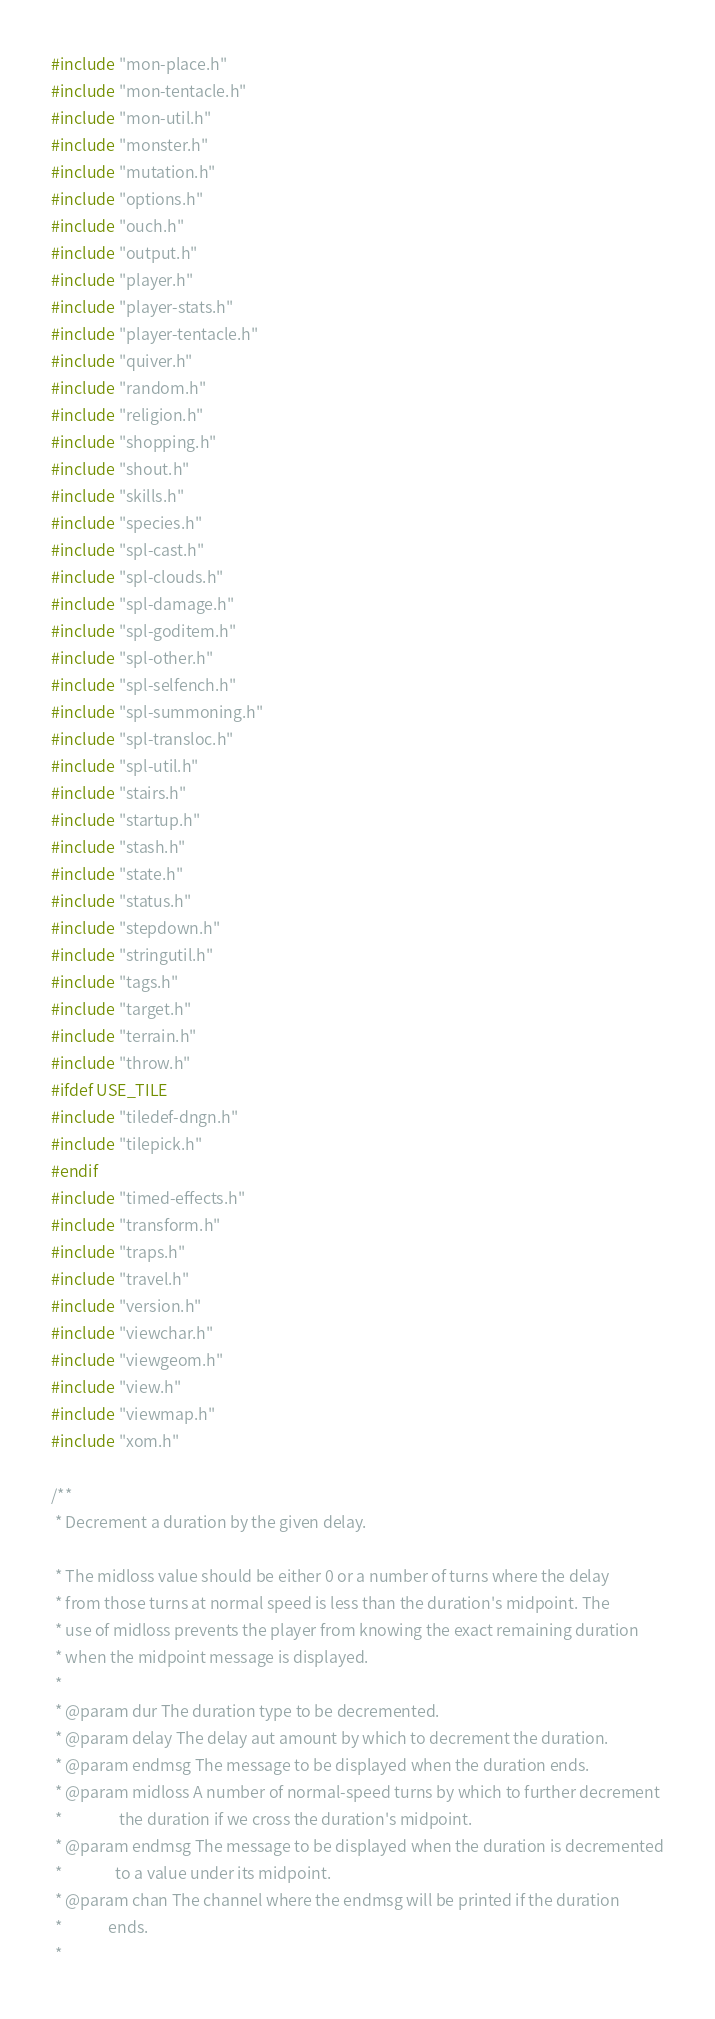Convert code to text. <code><loc_0><loc_0><loc_500><loc_500><_C++_>#include "mon-place.h"
#include "mon-tentacle.h"
#include "mon-util.h"
#include "monster.h"
#include "mutation.h"
#include "options.h"
#include "ouch.h"
#include "output.h"
#include "player.h"
#include "player-stats.h"
#include "player-tentacle.h"
#include "quiver.h"
#include "random.h"
#include "religion.h"
#include "shopping.h"
#include "shout.h"
#include "skills.h"
#include "species.h"
#include "spl-cast.h"
#include "spl-clouds.h"
#include "spl-damage.h"
#include "spl-goditem.h"
#include "spl-other.h"
#include "spl-selfench.h"
#include "spl-summoning.h"
#include "spl-transloc.h"
#include "spl-util.h"
#include "stairs.h"
#include "startup.h"
#include "stash.h"
#include "state.h"
#include "status.h"
#include "stepdown.h"
#include "stringutil.h"
#include "tags.h"
#include "target.h"
#include "terrain.h"
#include "throw.h"
#ifdef USE_TILE
#include "tiledef-dngn.h"
#include "tilepick.h"
#endif
#include "timed-effects.h"
#include "transform.h"
#include "traps.h"
#include "travel.h"
#include "version.h"
#include "viewchar.h"
#include "viewgeom.h"
#include "view.h"
#include "viewmap.h"
#include "xom.h"

/**
 * Decrement a duration by the given delay.

 * The midloss value should be either 0 or a number of turns where the delay
 * from those turns at normal speed is less than the duration's midpoint. The
 * use of midloss prevents the player from knowing the exact remaining duration
 * when the midpoint message is displayed.
 *
 * @param dur The duration type to be decremented.
 * @param delay The delay aut amount by which to decrement the duration.
 * @param endmsg The message to be displayed when the duration ends.
 * @param midloss A number of normal-speed turns by which to further decrement
 *                the duration if we cross the duration's midpoint.
 * @param endmsg The message to be displayed when the duration is decremented
 *               to a value under its midpoint.
 * @param chan The channel where the endmsg will be printed if the duration
 *             ends.
 *</code> 